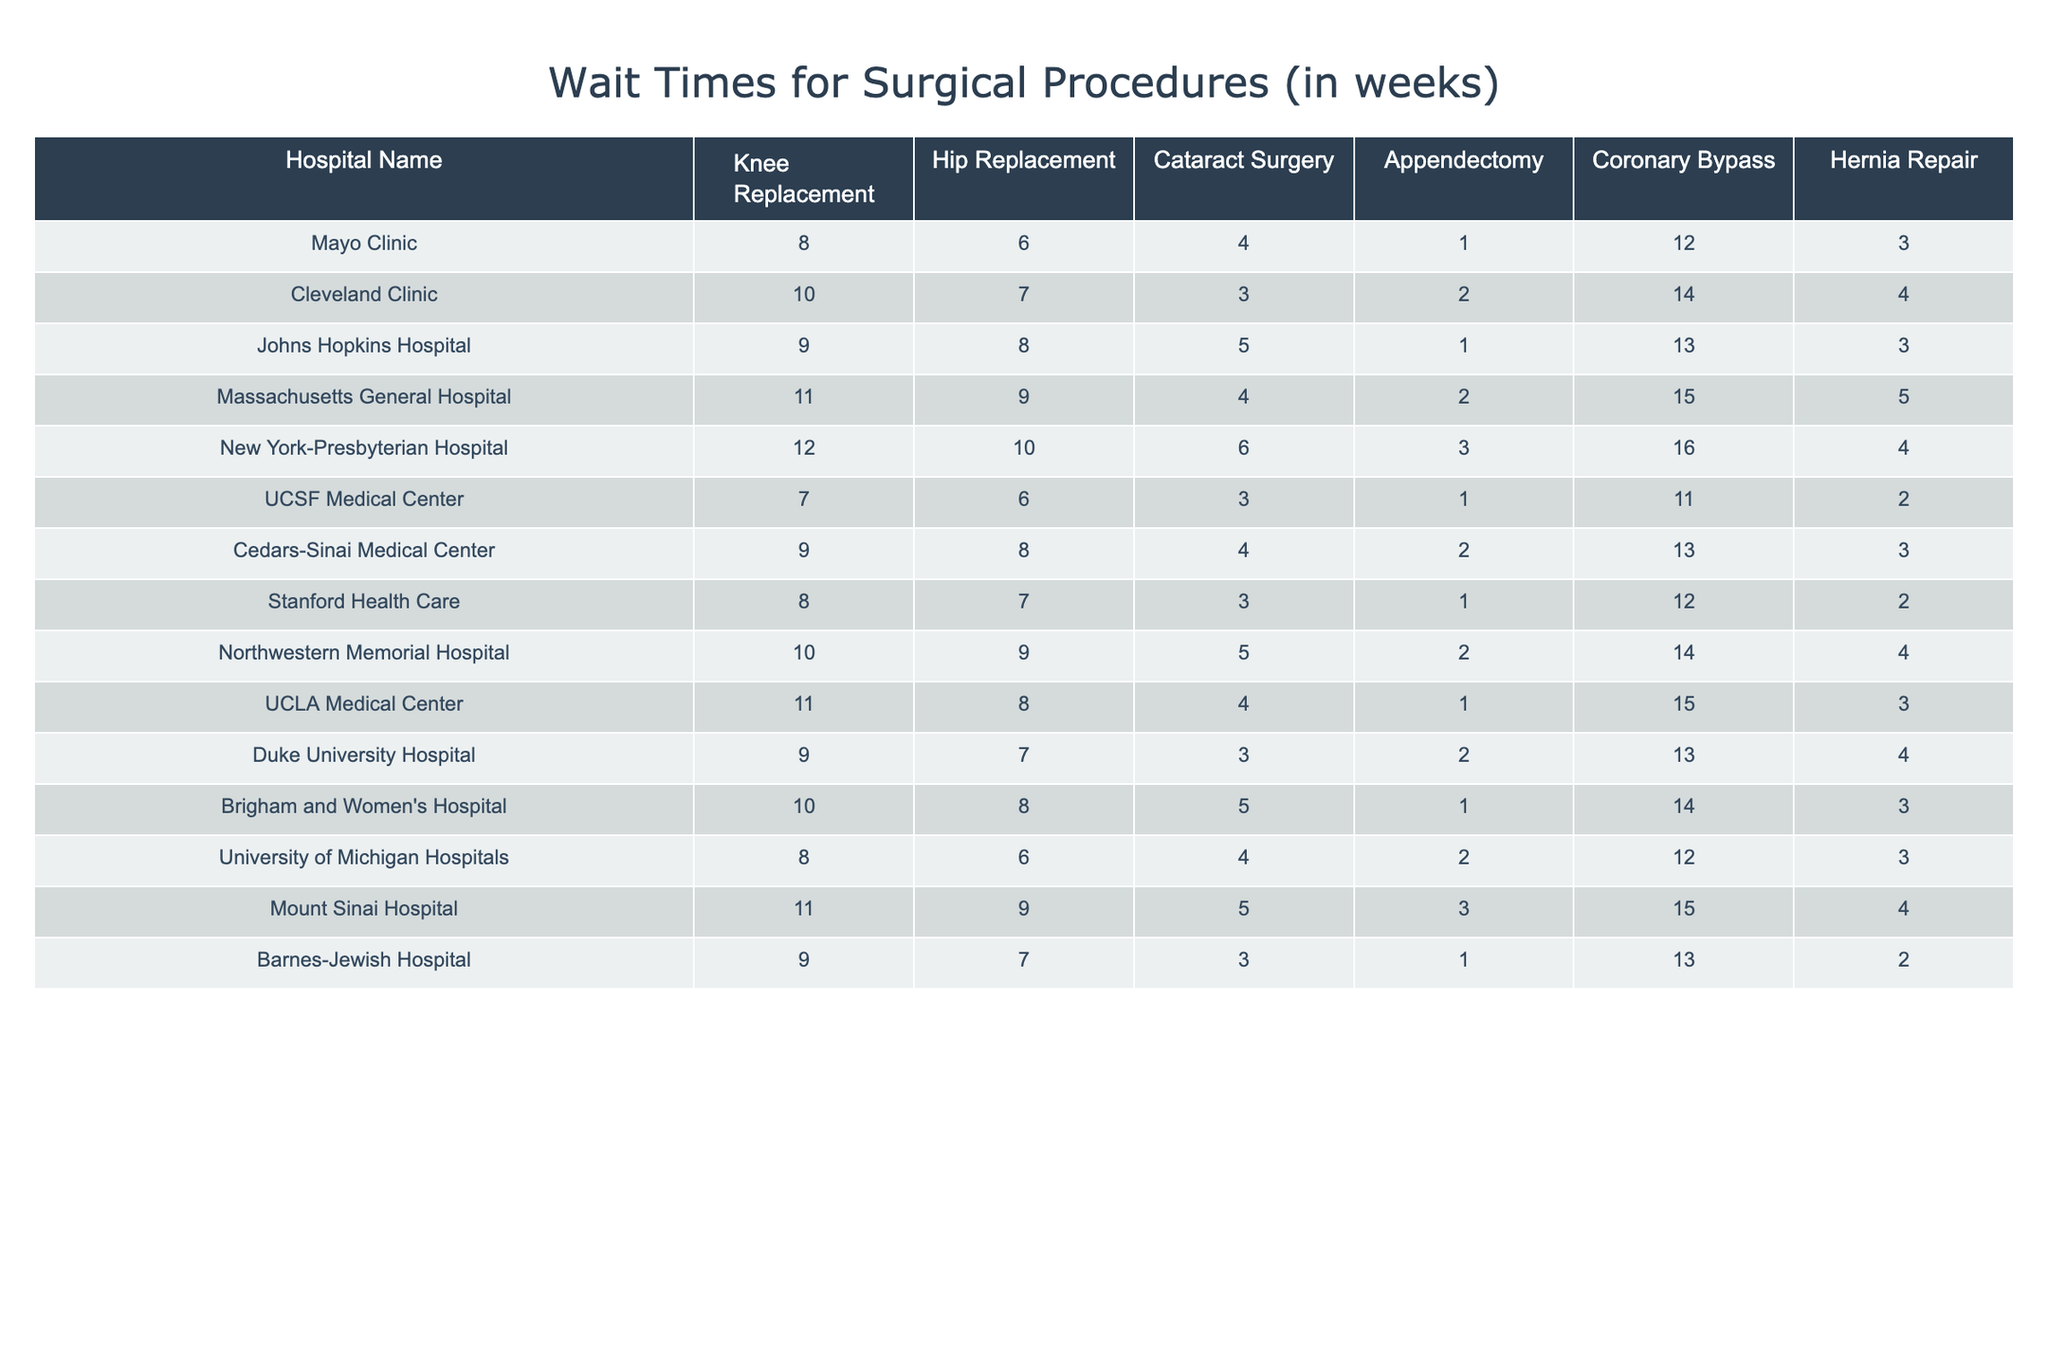What is the wait time for knee replacement surgery at Mayo Clinic? According to the table, the wait time for knee replacement surgery at Mayo Clinic is listed as 8 weeks.
Answer: 8 weeks Which hospital has the shortest wait time for cataract surgery? By looking at the table, UCSF Medical Center has the shortest wait time for cataract surgery at 3 weeks.
Answer: UCSF Medical Center What is the average wait time for hip replacement surgery across all hospitals? To find the average wait time for hip replacement surgery, sum the values (6 + 7 + 8 + 9 + 10 + 6 + 8 + 7 + 9 + 8 + 7 + 8 + 6 + 9 + 7) = 8.33 weeks. Since there are 15 hospitals, the average is approximately 8.3 weeks.
Answer: 8.3 weeks Is the wait time for appendectomy at New York-Presbyterian Hospital longer than at Duke University Hospital? New York-Presbyterian Hospital has a wait time of 3 weeks for appendectomy, while Duke University Hospital has a wait time of 2 weeks. Therefore, the wait time at New York-Presbyterian Hospital is longer than at Duke University Hospital.
Answer: Yes Which hospital has the longest wait time for coronary bypass surgery? The table shows that New York-Presbyterian Hospital has the longest wait time for coronary bypass surgery at 16 weeks, which is greater than the others.
Answer: New York-Presbyterian Hospital What is the total wait time for all surgical procedures at Massachusetts General Hospital? The total wait time at Massachusetts General Hospital can be calculated by summing the wait times: 11 + 9 + 4 + 2 + 15 + 5 = 46 weeks.
Answer: 46 weeks True or False: Johns Hopkins Hospital has a shorter wait time for hernia repair compared to Mayo Clinic. Johns Hopkins Hospital has a wait time of 3 weeks for hernia repair, while Mayo Clinic has a wait time of 3 weeks as well. Thus, they are equal, so the statement is false.
Answer: False What is the difference in wait times for knee replacement surgery between the hospital with the shortest and the longest wait times? The hospital with the shortest wait time for knee replacement surgery is UCSF Medical Center at 7 weeks, and the longest is New York-Presbyterian Hospital at 12 weeks. The difference is 12 - 7 = 5 weeks.
Answer: 5 weeks What is the second shortest wait time for hernia repair across all hospitals? When looking at the hernia repair wait times, the shortest is at UCSF Medical Center with 2 weeks, and the next shortest is at several hospitals with 3 weeks (Mayo Clinic, Johns Hopkins Hospital, Cedars-Sinai Medical Center, UCLA Medical Center, Duke University Hospital, and Brigham and Women's Hospital). Therefore, the second shortest wait time is 3 weeks.
Answer: 3 weeks Calculate the average wait time for all surgeries at Cleveland Clinic. The wait times at Cleveland Clinic are: Knee Replacement - 10, Hip Replacement - 7, Cataract Surgery - 3, Appendectomy - 2, Coronary Bypass - 14, Hernia Repair - 4. The total is 10 + 7 + 3 + 2 + 14 + 4 = 40 weeks. There are 6 procedures, so the average wait time is 40 / 6 = 6.67 weeks.
Answer: 6.67 weeks 